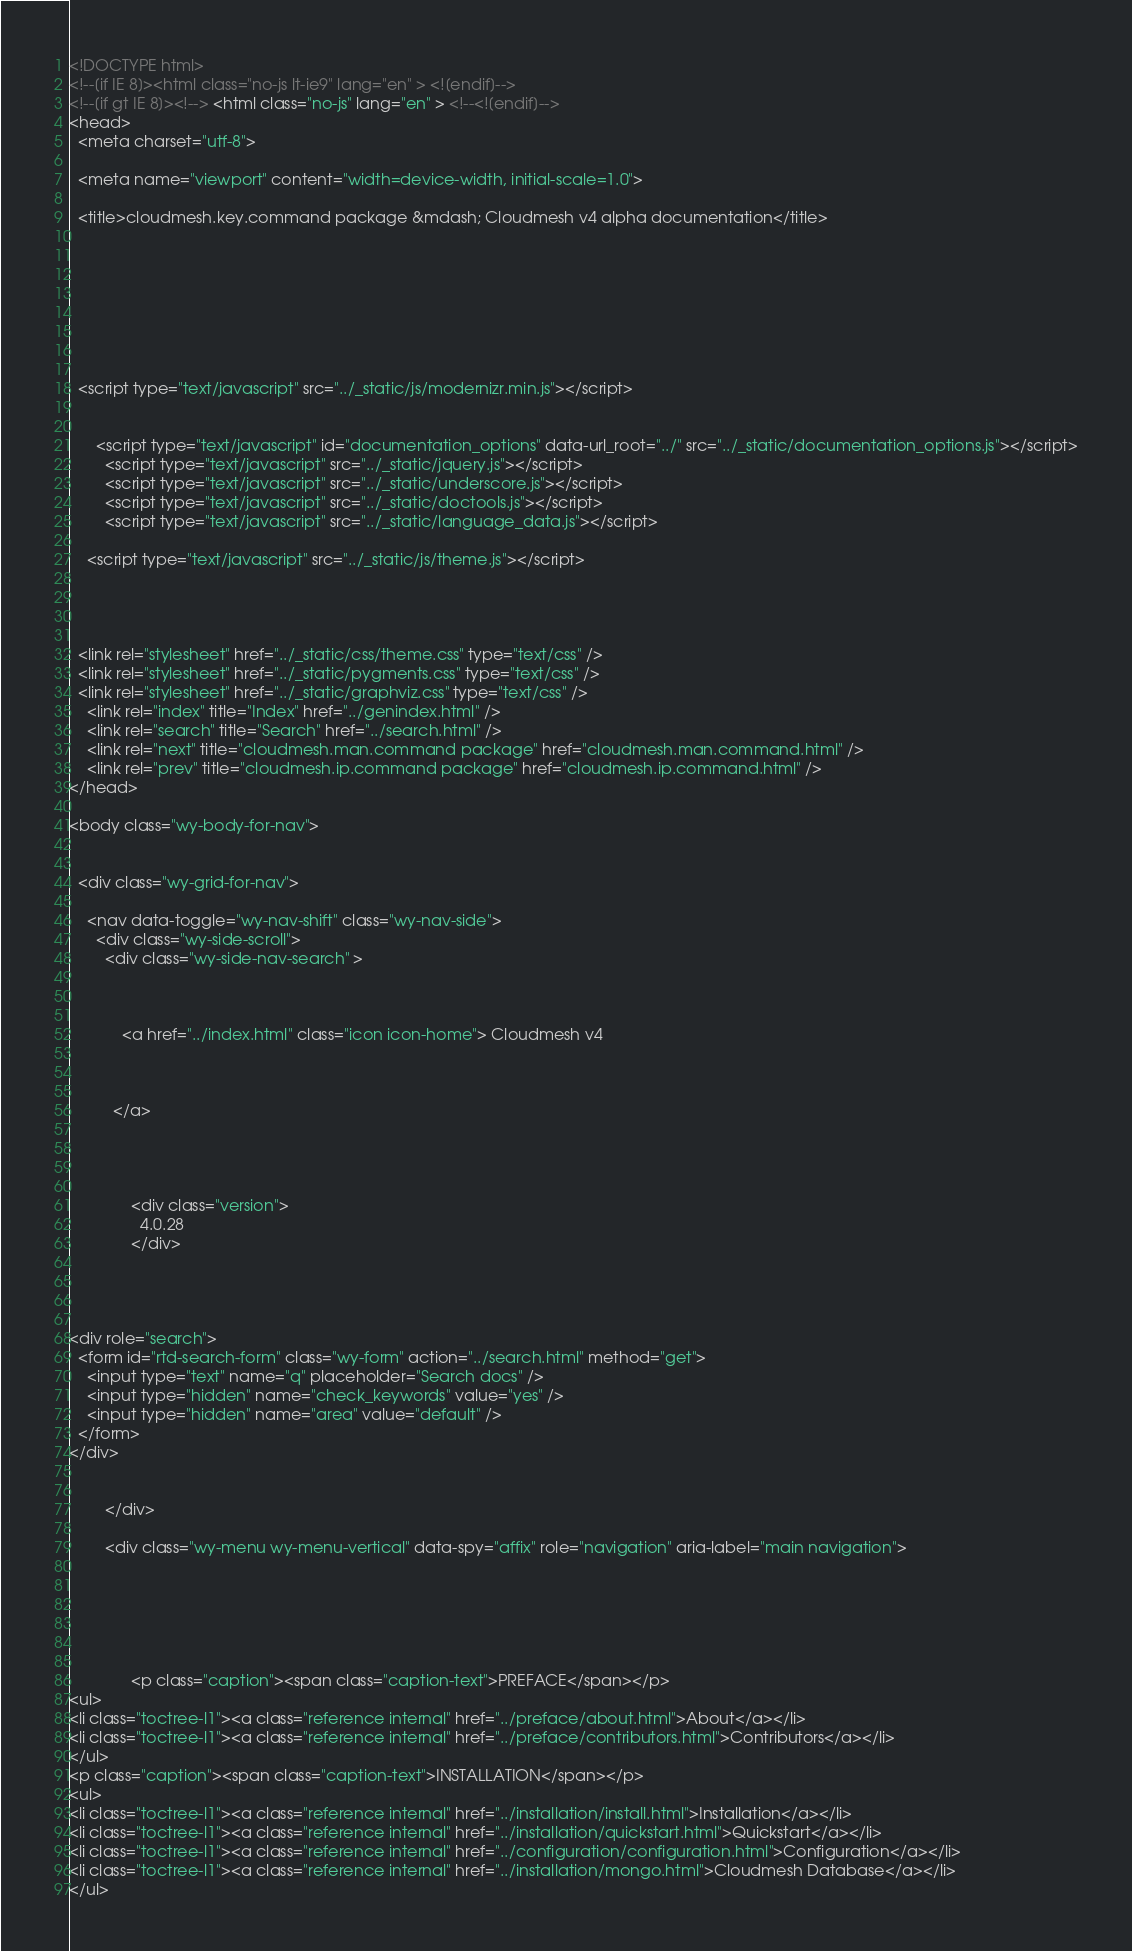<code> <loc_0><loc_0><loc_500><loc_500><_HTML_>

<!DOCTYPE html>
<!--[if IE 8]><html class="no-js lt-ie9" lang="en" > <![endif]-->
<!--[if gt IE 8]><!--> <html class="no-js" lang="en" > <!--<![endif]-->
<head>
  <meta charset="utf-8">
  
  <meta name="viewport" content="width=device-width, initial-scale=1.0">
  
  <title>cloudmesh.key.command package &mdash; Cloudmesh v4 alpha documentation</title>
  

  
  
  
  

  
  <script type="text/javascript" src="../_static/js/modernizr.min.js"></script>
  
    
      <script type="text/javascript" id="documentation_options" data-url_root="../" src="../_static/documentation_options.js"></script>
        <script type="text/javascript" src="../_static/jquery.js"></script>
        <script type="text/javascript" src="../_static/underscore.js"></script>
        <script type="text/javascript" src="../_static/doctools.js"></script>
        <script type="text/javascript" src="../_static/language_data.js"></script>
    
    <script type="text/javascript" src="../_static/js/theme.js"></script>

    

  
  <link rel="stylesheet" href="../_static/css/theme.css" type="text/css" />
  <link rel="stylesheet" href="../_static/pygments.css" type="text/css" />
  <link rel="stylesheet" href="../_static/graphviz.css" type="text/css" />
    <link rel="index" title="Index" href="../genindex.html" />
    <link rel="search" title="Search" href="../search.html" />
    <link rel="next" title="cloudmesh.man.command package" href="cloudmesh.man.command.html" />
    <link rel="prev" title="cloudmesh.ip.command package" href="cloudmesh.ip.command.html" /> 
</head>

<body class="wy-body-for-nav">

   
  <div class="wy-grid-for-nav">
    
    <nav data-toggle="wy-nav-shift" class="wy-nav-side">
      <div class="wy-side-scroll">
        <div class="wy-side-nav-search" >
          

          
            <a href="../index.html" class="icon icon-home"> Cloudmesh v4
          

          
          </a>

          
            
            
              <div class="version">
                4.0.28
              </div>
            
          

          
<div role="search">
  <form id="rtd-search-form" class="wy-form" action="../search.html" method="get">
    <input type="text" name="q" placeholder="Search docs" />
    <input type="hidden" name="check_keywords" value="yes" />
    <input type="hidden" name="area" value="default" />
  </form>
</div>

          
        </div>

        <div class="wy-menu wy-menu-vertical" data-spy="affix" role="navigation" aria-label="main navigation">
          
            
            
              
            
            
              <p class="caption"><span class="caption-text">PREFACE</span></p>
<ul>
<li class="toctree-l1"><a class="reference internal" href="../preface/about.html">About</a></li>
<li class="toctree-l1"><a class="reference internal" href="../preface/contributors.html">Contributors</a></li>
</ul>
<p class="caption"><span class="caption-text">INSTALLATION</span></p>
<ul>
<li class="toctree-l1"><a class="reference internal" href="../installation/install.html">Installation</a></li>
<li class="toctree-l1"><a class="reference internal" href="../installation/quickstart.html">Quickstart</a></li>
<li class="toctree-l1"><a class="reference internal" href="../configuration/configuration.html">Configuration</a></li>
<li class="toctree-l1"><a class="reference internal" href="../installation/mongo.html">Cloudmesh Database</a></li>
</ul></code> 